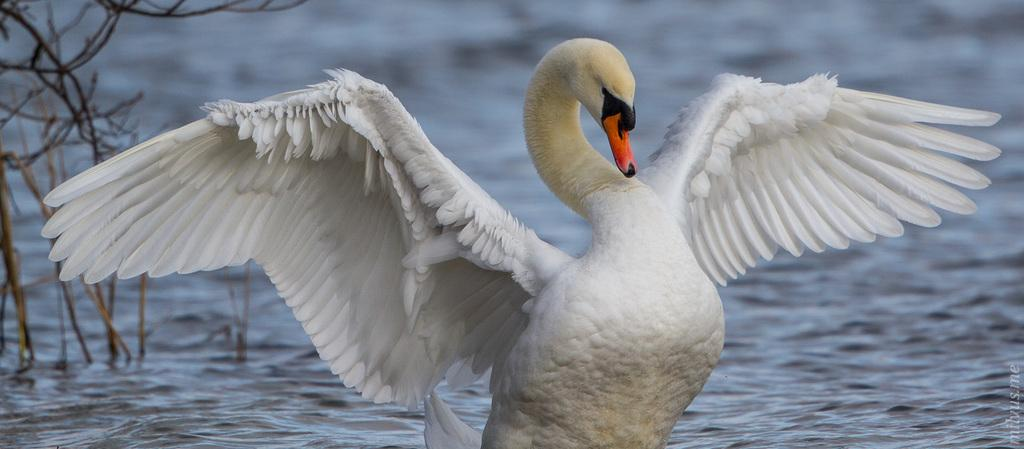What is the main subject in the foreground of the image? There is a bird in the foreground of the image. What can be seen in the background of the image? There is a water body in the background of the image. What type of vegetation is present on the left side of the image? There are plants on the left side of the image. Where is the library located in the image? There is no library present in the image. Can you hear the bird whistling in the image? The image is silent, and there is no indication of any sound, including whistling. 